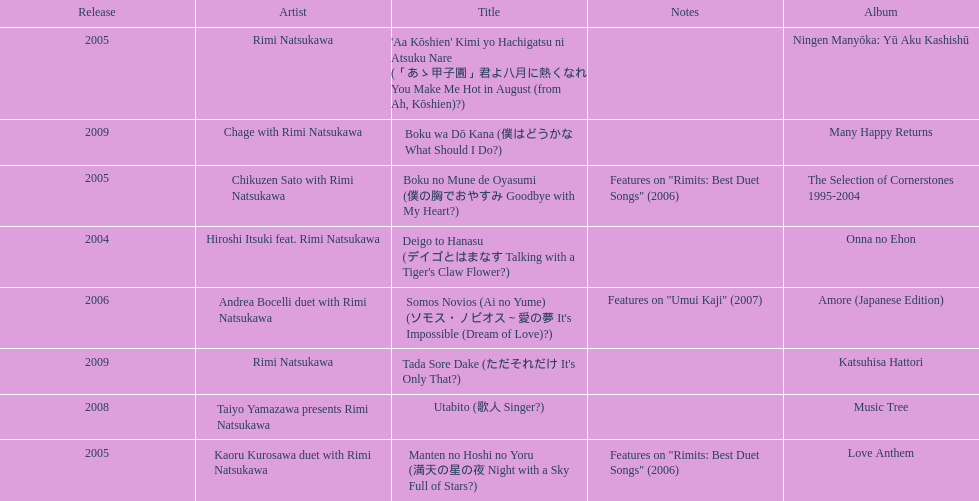What is the last title released? 2009. 